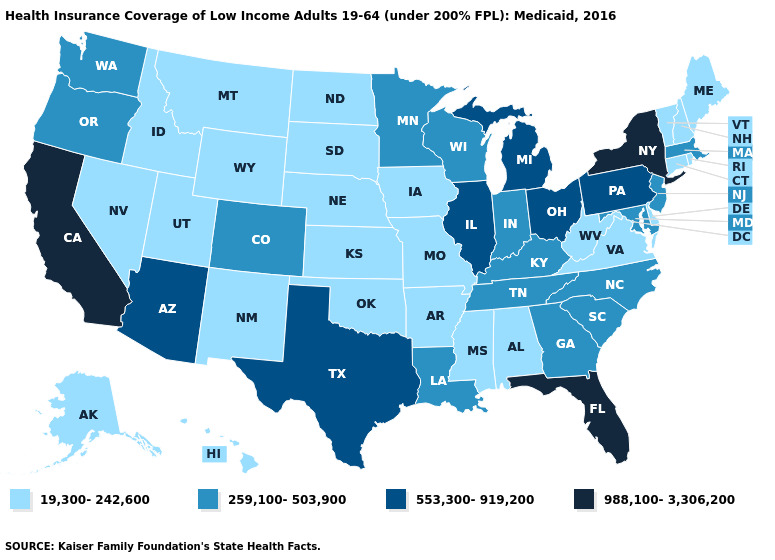Name the states that have a value in the range 553,300-919,200?
Concise answer only. Arizona, Illinois, Michigan, Ohio, Pennsylvania, Texas. Does Minnesota have the lowest value in the MidWest?
Be succinct. No. What is the value of South Carolina?
Keep it brief. 259,100-503,900. Does Delaware have the highest value in the USA?
Quick response, please. No. What is the value of Maryland?
Be succinct. 259,100-503,900. Name the states that have a value in the range 988,100-3,306,200?
Concise answer only. California, Florida, New York. Does California have the highest value in the West?
Answer briefly. Yes. Does Missouri have the lowest value in the USA?
Short answer required. Yes. What is the value of Texas?
Give a very brief answer. 553,300-919,200. What is the value of Wisconsin?
Keep it brief. 259,100-503,900. What is the value of Georgia?
Concise answer only. 259,100-503,900. Does the map have missing data?
Answer briefly. No. Which states hav the highest value in the West?
Write a very short answer. California. Does Hawaii have a higher value than Montana?
Be succinct. No. Name the states that have a value in the range 988,100-3,306,200?
Be succinct. California, Florida, New York. 